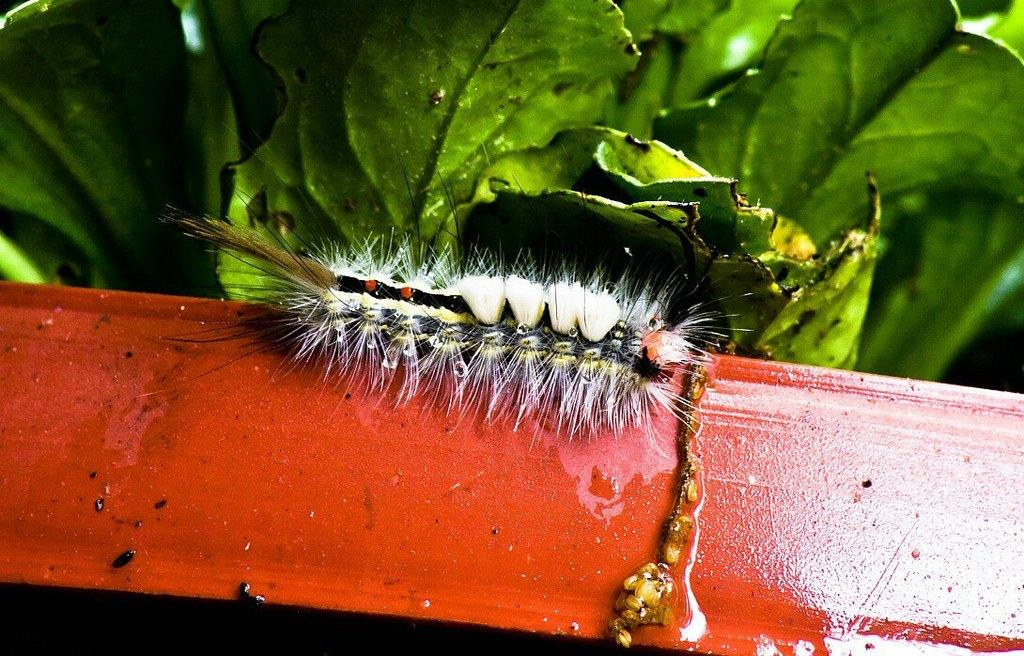What type of creature is present in the image? There is an insect in the image. What is the insect situated on? The insect is on a red object. What can be seen in the background of the image? There are leaves visible in the background of the image. How many advertisements can be seen in the image? There are no advertisements present in the image. What type of hearing device is visible in the image? There is no hearing device visible in the image. 